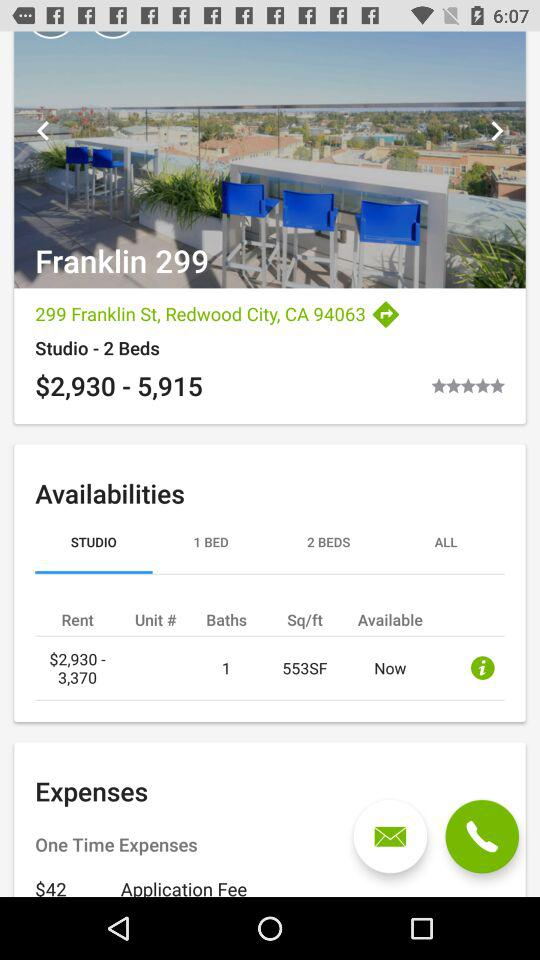Which option is selected? The selected option is "STUDIO". 